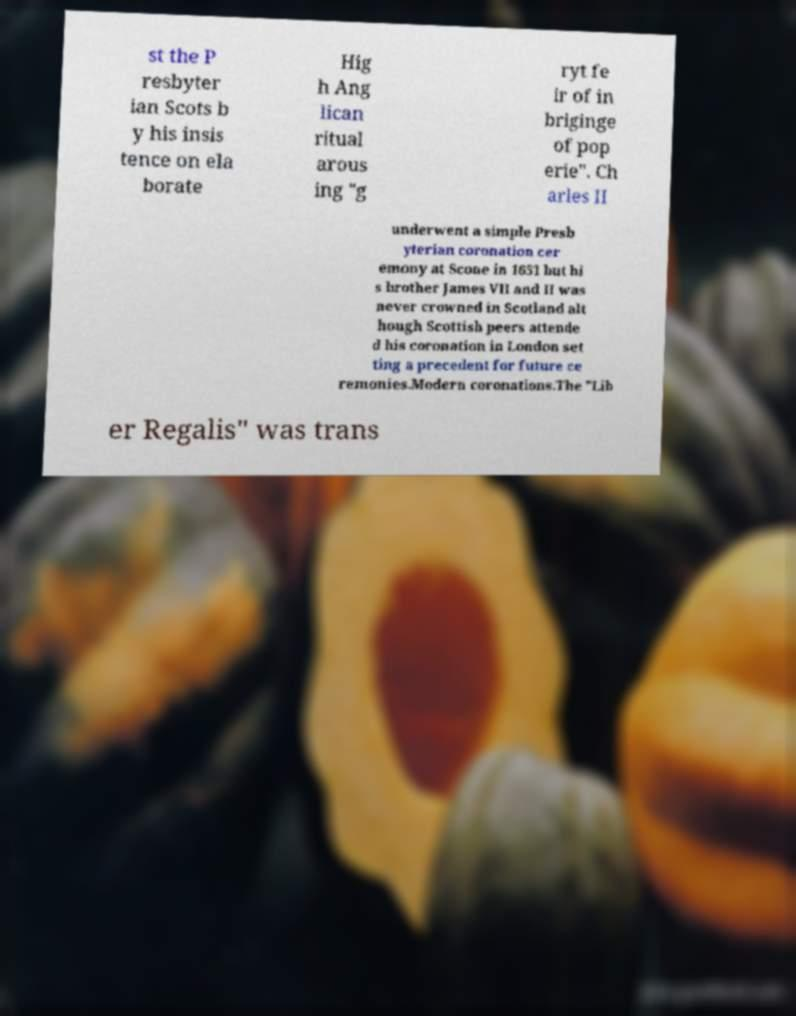There's text embedded in this image that I need extracted. Can you transcribe it verbatim? st the P resbyter ian Scots b y his insis tence on ela borate Hig h Ang lican ritual arous ing "g ryt fe ir of in briginge of pop erie". Ch arles II underwent a simple Presb yterian coronation cer emony at Scone in 1651 but hi s brother James VII and II was never crowned in Scotland alt hough Scottish peers attende d his coronation in London set ting a precedent for future ce remonies.Modern coronations.The "Lib er Regalis" was trans 